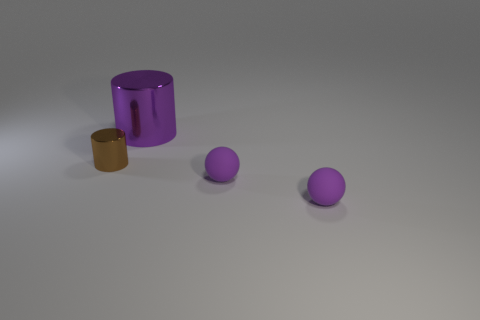Are there any other objects that have the same color as the big thing?
Provide a short and direct response. Yes. How many other things are there of the same material as the brown thing?
Give a very brief answer. 1. Are any large yellow rubber objects visible?
Keep it short and to the point. No. Are there the same number of large cylinders that are on the left side of the purple shiny cylinder and large cyan metallic balls?
Keep it short and to the point. Yes. What number of other objects are the same shape as the big purple object?
Your answer should be compact. 1. What is the shape of the big shiny thing?
Provide a succinct answer. Cylinder. Does the big cylinder have the same material as the brown object?
Provide a succinct answer. Yes. Are there an equal number of purple metallic objects that are in front of the large cylinder and big purple objects on the right side of the brown metal cylinder?
Provide a succinct answer. No. Are there any purple things in front of the cylinder that is in front of the cylinder that is behind the small cylinder?
Make the answer very short. Yes. What is the color of the shiny cylinder that is in front of the thing behind the cylinder that is in front of the large purple shiny cylinder?
Ensure brevity in your answer.  Brown. 